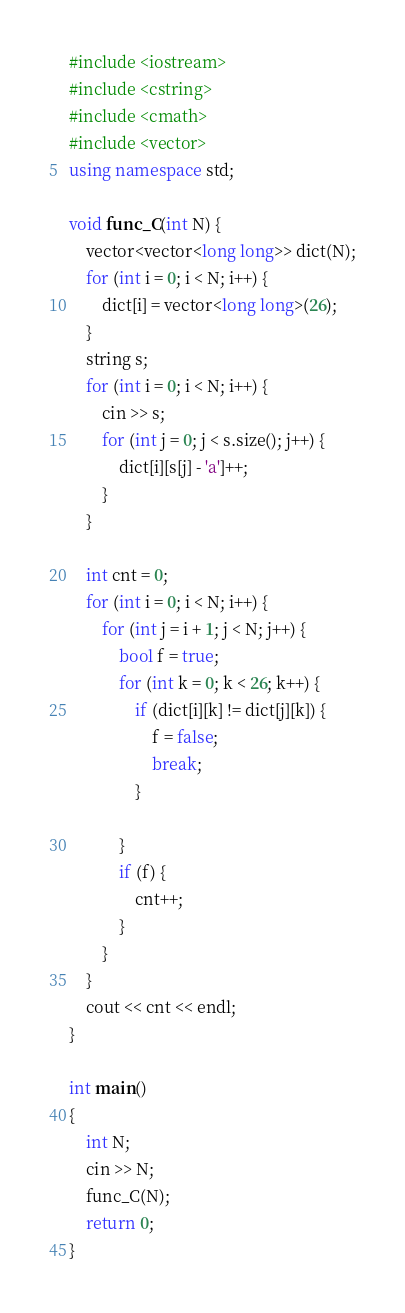Convert code to text. <code><loc_0><loc_0><loc_500><loc_500><_C++_>#include <iostream>
#include <cstring>
#include <cmath>
#include <vector>
using namespace std;

void func_C(int N) {
	vector<vector<long long>> dict(N);
	for (int i = 0; i < N; i++) {
		dict[i] = vector<long long>(26);
	}
	string s;
	for (int i = 0; i < N; i++) {
		cin >> s;
		for (int j = 0; j < s.size(); j++) {
			dict[i][s[j] - 'a']++;
		}
	}

	int cnt = 0;
	for (int i = 0; i < N; i++) {
		for (int j = i + 1; j < N; j++) {
			bool f = true;
			for (int k = 0; k < 26; k++) {
				if (dict[i][k] != dict[j][k]) {
					f = false;
					break;
				}
				
			}
			if (f) {
				cnt++;
			}
		}
	}
	cout << cnt << endl;
}

int main()
{
	int N;
	cin >> N;
	func_C(N);
	return 0;
}</code> 